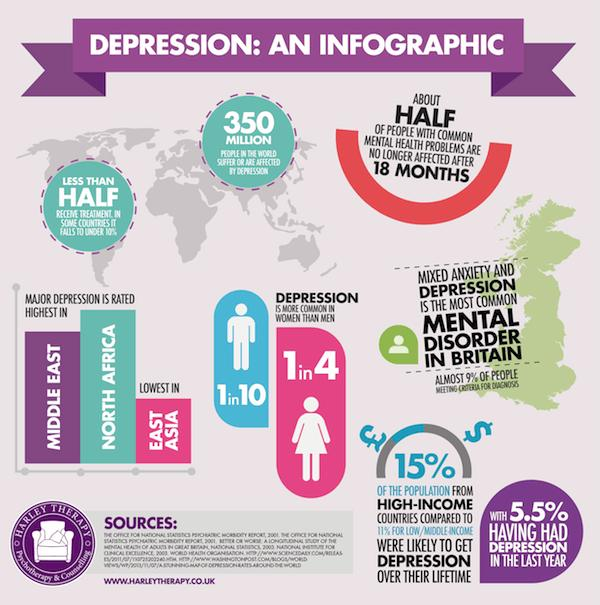Mention a couple of crucial points in this snapshot. According to estimates, approximately 10% of men are affected by depression. According to the data provided, North Africa has the highest rate of depression among all regions. In high-income countries, a greater percentage of people were effectively treated for depression compared to low/middle income countries, with a difference of 4%. It is estimated that approximately 350 million people in the world suffer from depression. Nearly 25% of women are affected by depression. 